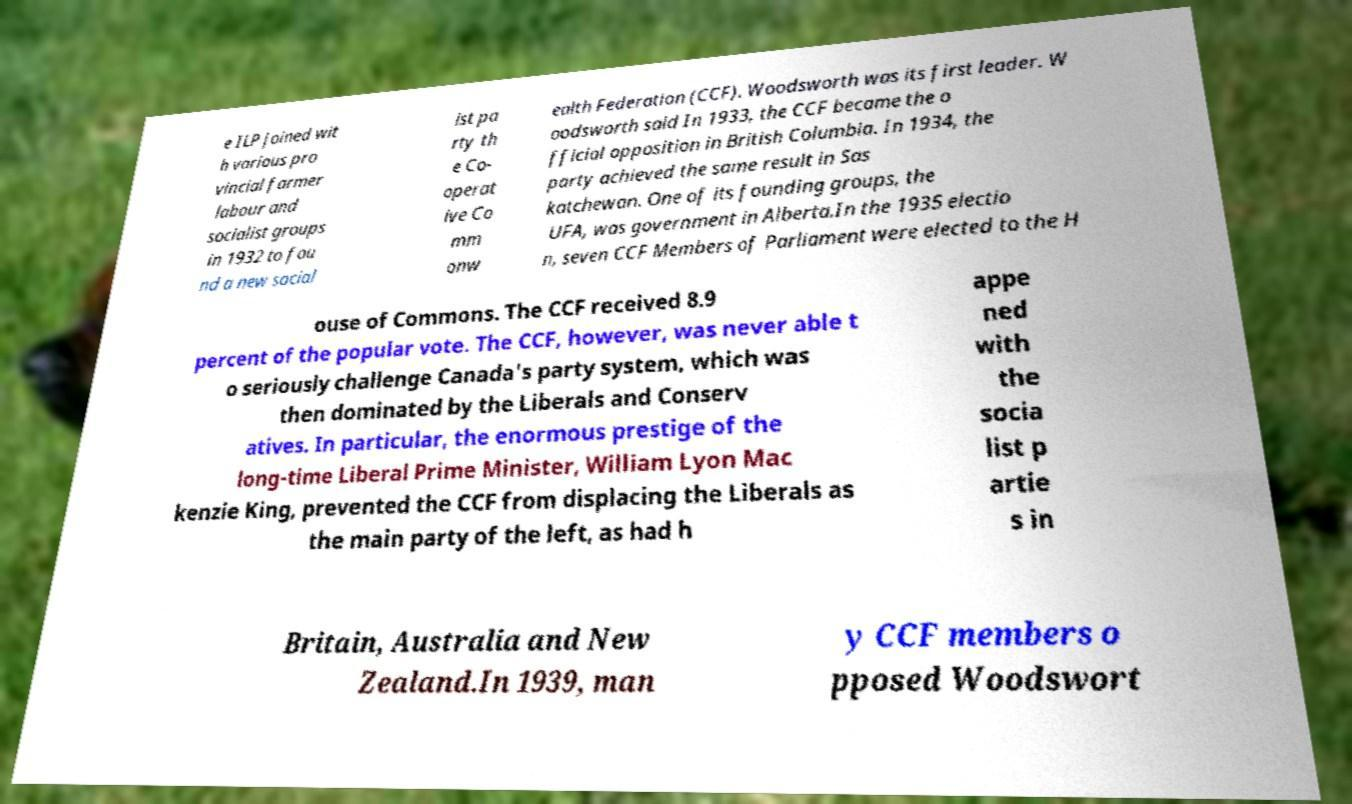Can you accurately transcribe the text from the provided image for me? e ILP joined wit h various pro vincial farmer labour and socialist groups in 1932 to fou nd a new social ist pa rty th e Co- operat ive Co mm onw ealth Federation (CCF). Woodsworth was its first leader. W oodsworth said In 1933, the CCF became the o fficial opposition in British Columbia. In 1934, the party achieved the same result in Sas katchewan. One of its founding groups, the UFA, was government in Alberta.In the 1935 electio n, seven CCF Members of Parliament were elected to the H ouse of Commons. The CCF received 8.9 percent of the popular vote. The CCF, however, was never able t o seriously challenge Canada's party system, which was then dominated by the Liberals and Conserv atives. In particular, the enormous prestige of the long-time Liberal Prime Minister, William Lyon Mac kenzie King, prevented the CCF from displacing the Liberals as the main party of the left, as had h appe ned with the socia list p artie s in Britain, Australia and New Zealand.In 1939, man y CCF members o pposed Woodswort 